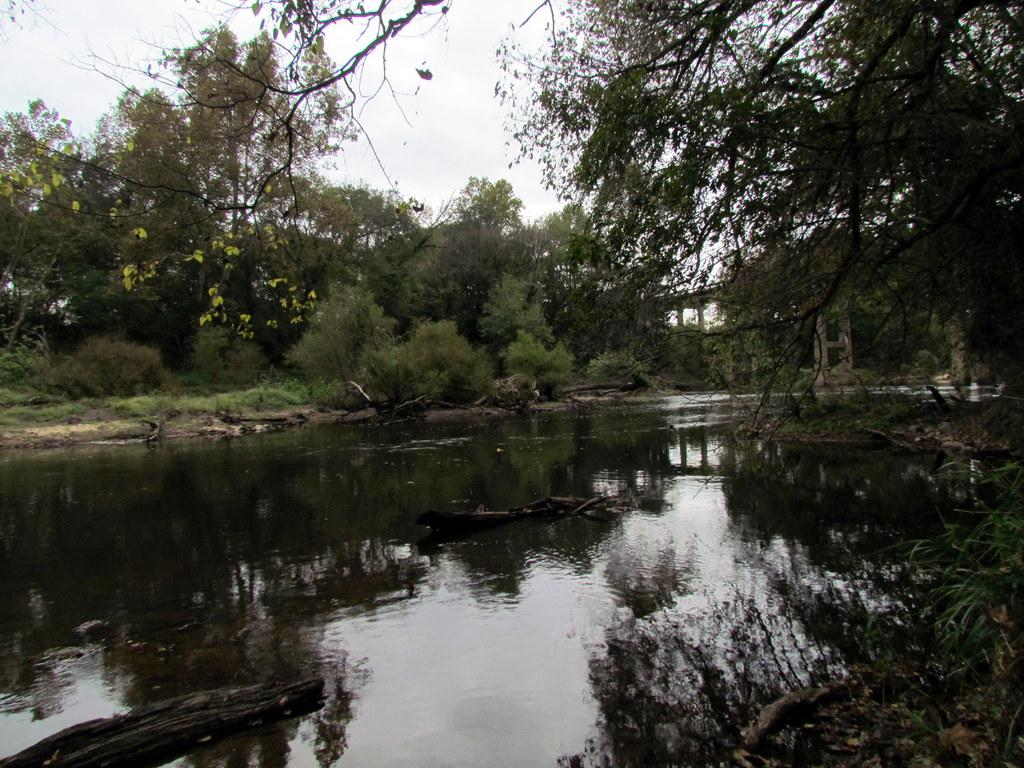What type of natural body of water is present in the image? There is a lake in the image. What can be found on the ground near the lake? There are plants on the ground. What is visible in the background of the image? There are trees and the sky visible in the background of the image. What type of shoe is being used to pay off the debt in the image? There is no shoe or debt present in the image; it features a lake, plants, trees, and the sky. 